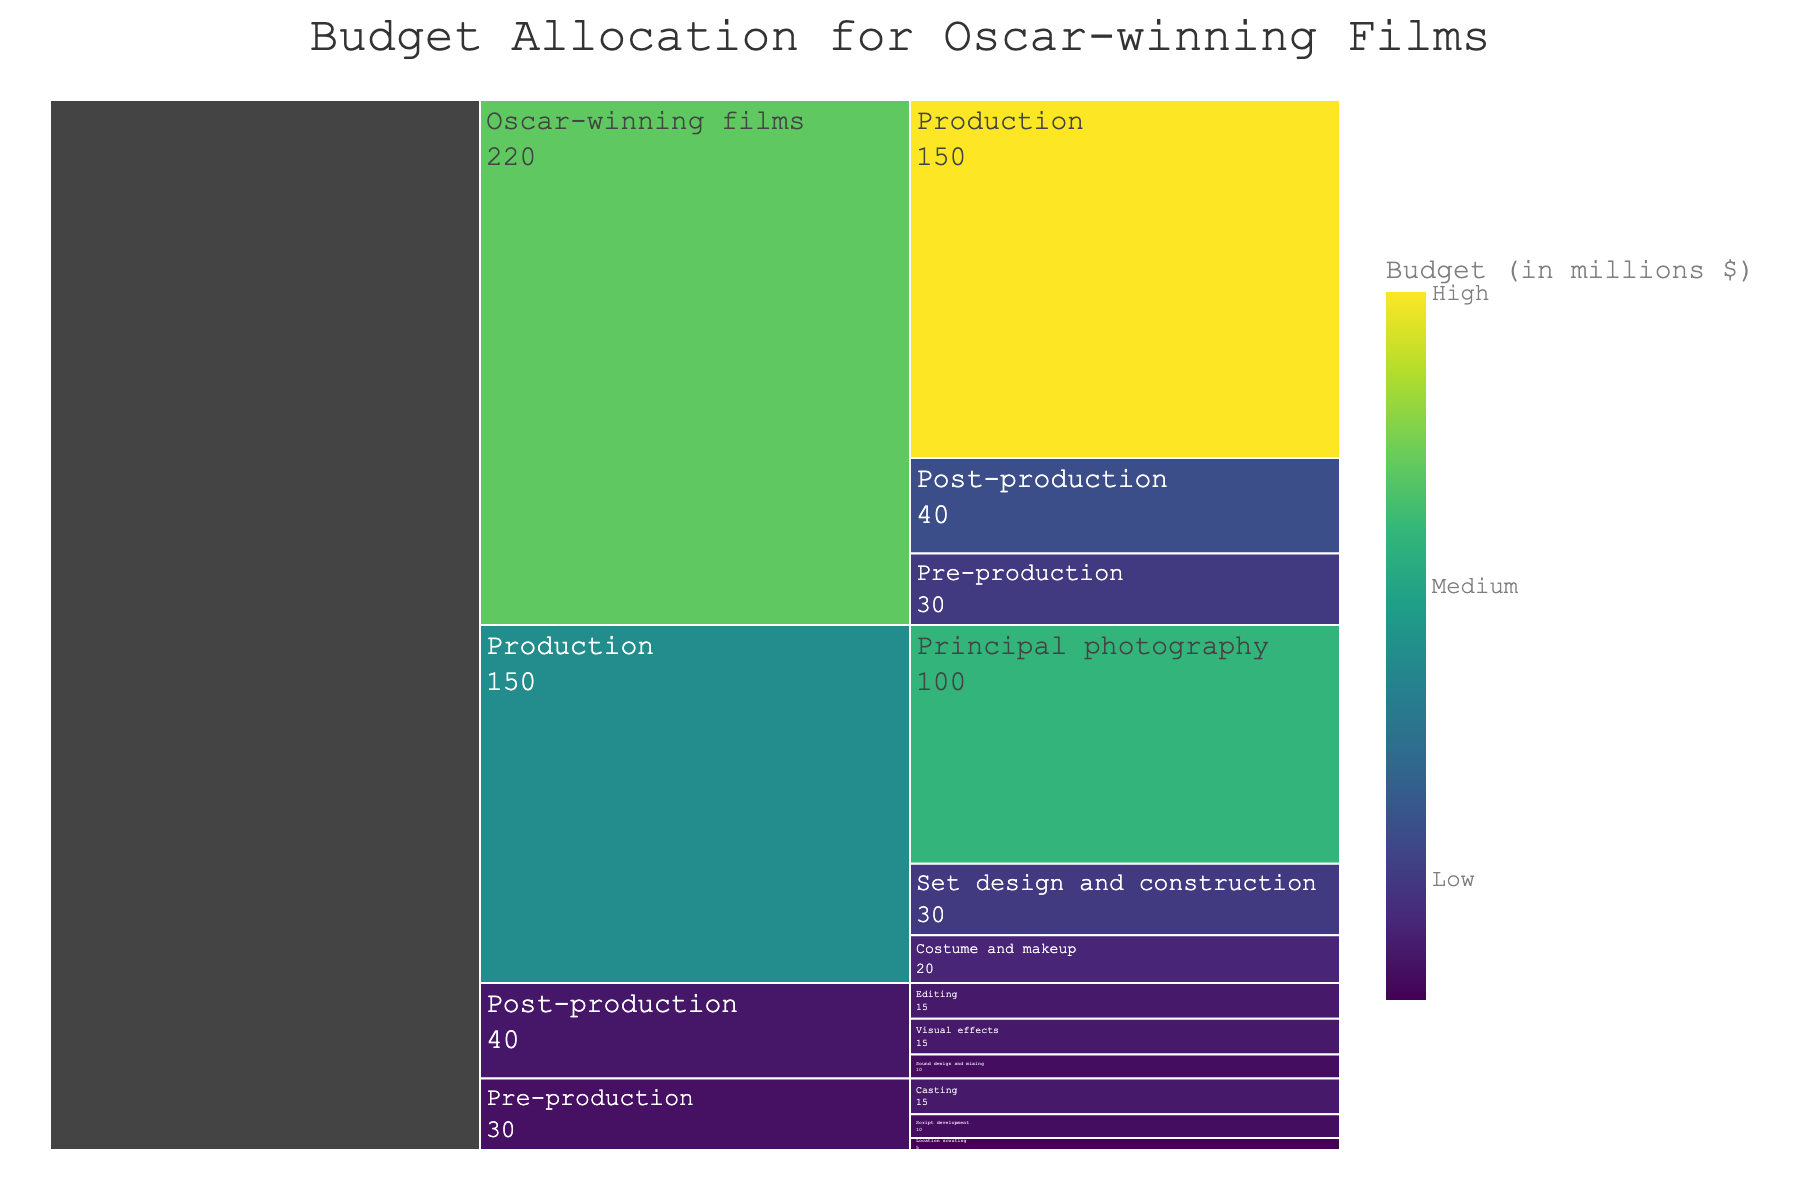What is the total budget allocation for the 'Pre-production' phase? The 'Pre-production' phase has three subcategories with the following budgets: Script development (10), Location scouting (5), and Casting (15). Adding these gives 10 + 5 + 15 = 30.
Answer: 30 Which phase has the highest budget allocation? The chart shows three main phases: Pre-production (30), Production (150), and Post-production (40). The phase with the highest budget is Production with 150.
Answer: Production What is the budget allocation for 'Visual effects' in the Post-production phase? In the 'Post-production' phase, the chart lists Visual effects with a budget of 15.
Answer: 15 How much of the Production budget is allocated to 'Set design and construction'? The chart shows that the 'Set design and construction' subcategory has a budget of 30 out of the total 150 for Production.
Answer: 30 Compare the budget allocations for 'Costume and makeup' and 'Editing'. Which one is higher and by how much? 'Costume and makeup' in the Production phase has a budget of 20, while 'Editing' in Post-production has 15. The difference is 20 - 15 = 5, with Costume and makeup being higher.
Answer: Costume and makeup by 5 What is the combined budget for 'Casting' and 'Location scouting' in the Pre-production phase? In the 'Pre-production' phase, 'Casting' has a budget of 15, and 'Location scouting' has 5. Combined, it is 15 + 5 = 20.
Answer: 20 What percent of the total Production budget is allocated to 'Principal photography'? The 'Principal photography' has a budget of 100 out of the total Production budget of 150. The percentage is (100/150) * 100 = 66.67%.
Answer: 66.67% How does the budget allocation for 'Sound design and mixing' compare to 'Script development'? 'Sound design and mixing' has a budget of 10 in the Post-production phase, while 'Script development' has 10 in the Pre-production phase. Both have the same budget allocation.
Answer: Same What is the total budget allocation across all phases? The three phases have the following budgets: Pre-production (30), Production (150), and Post-production (40). Adding these gives 30 + 150 + 40 = 220.
Answer: 220 Which subcategory has the highest budget allocation within the Production phase? Within the Production phase, 'Principal photography' has the highest budget allocation with 100.
Answer: Principal photography 